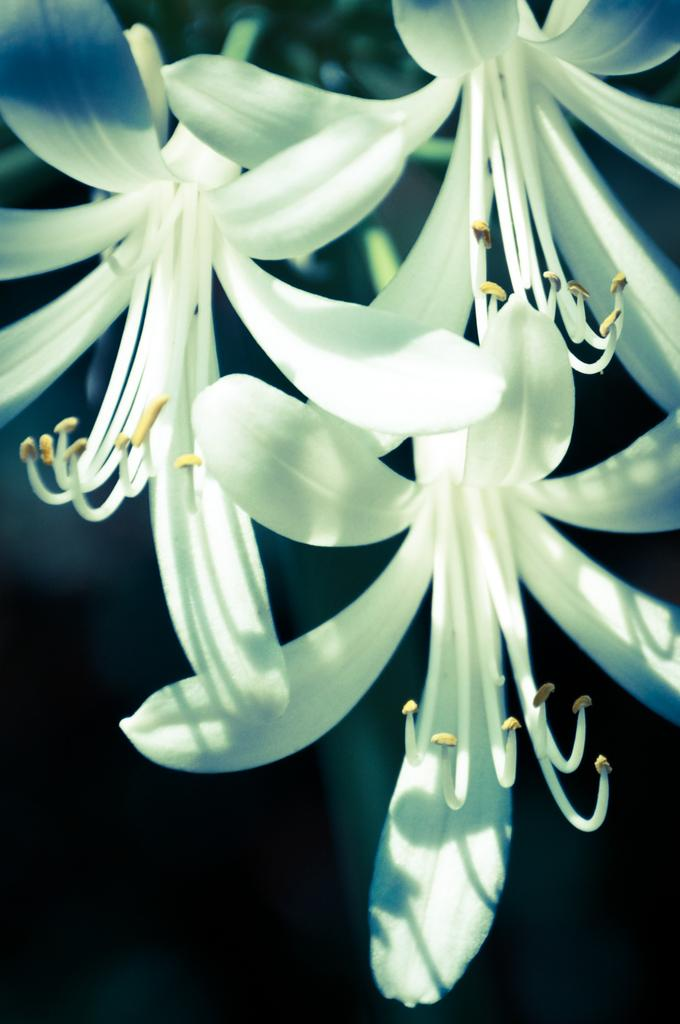What type of flowers can be seen in the image? There are white color flowers in the image. Where are the flowers located in the image? The flowers are located in the middle of the image. What type of metal is the tank made of in the image? There is no tank present in the image, so it is not possible to determine the type of metal it might be made of. 